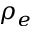<formula> <loc_0><loc_0><loc_500><loc_500>\rho _ { e }</formula> 